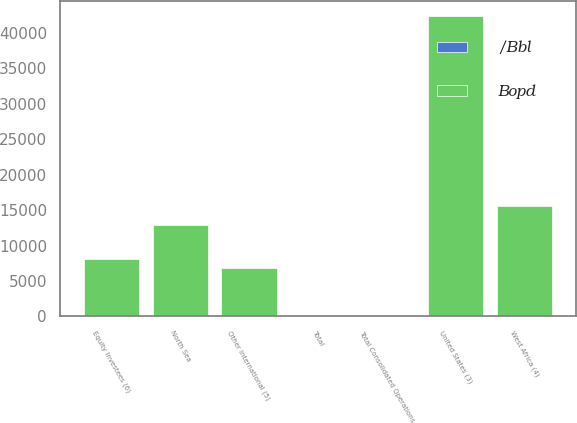Convert chart. <chart><loc_0><loc_0><loc_500><loc_500><stacked_bar_chart><ecel><fcel>United States (3)<fcel>West Africa (4)<fcel>North Sea<fcel>Other International (5)<fcel>Total Consolidated Operations<fcel>Equity Investees (6)<fcel>Total<nl><fcel>Bopd<fcel>42332<fcel>15523<fcel>12813<fcel>6806<fcel>73.87<fcel>8014<fcel>73.87<nl><fcel>/Bbl<fcel>53.22<fcel>71.27<fcel>76.47<fcel>53.69<fcel>60.61<fcel>55.09<fcel>60.1<nl></chart> 